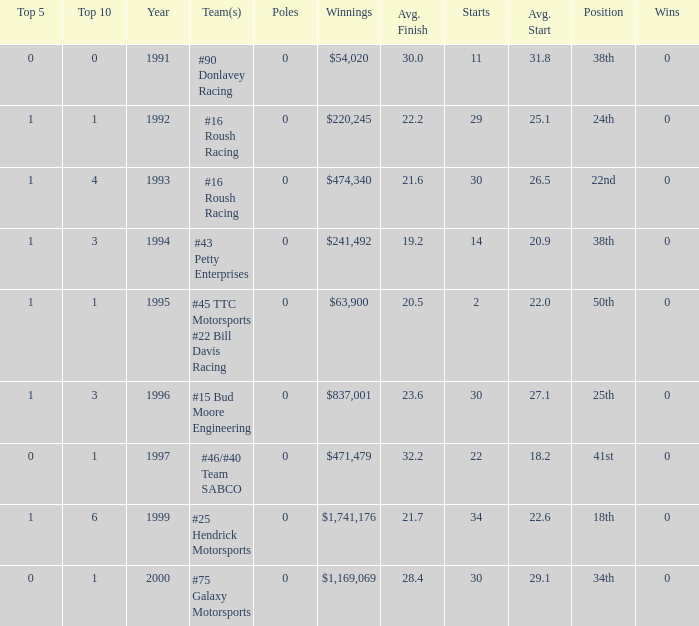What the rank in the top 10 when the  winnings were $1,741,176? 6.0. 